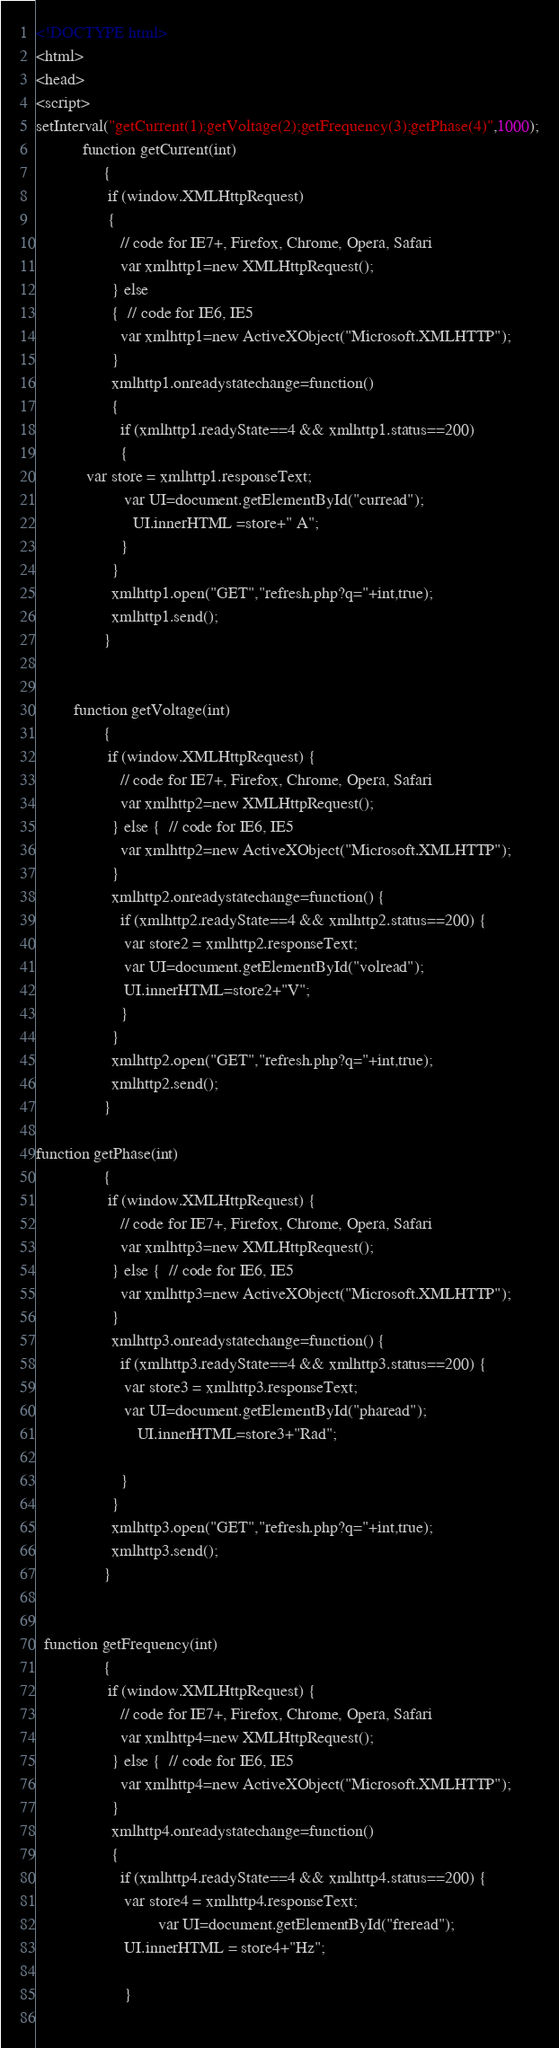Convert code to text. <code><loc_0><loc_0><loc_500><loc_500><_HTML_><!DOCTYPE html>
<html>
<head>
<script>
setInterval("getCurrent(1);getVoltage(2);getFrequency(3);getPhase(4)",1000);
           function getCurrent(int) 
				{
				 if (window.XMLHttpRequest)
				 {
					// code for IE7+, Firefox, Chrome, Opera, Safari
					var xmlhttp1=new XMLHttpRequest();
				  } else 
				  {  // code for IE6, IE5
					var xmlhttp1=new ActiveXObject("Microsoft.XMLHTTP");
				  }
				  xmlhttp1.onreadystatechange=function()
				  {
					if (xmlhttp1.readyState==4 && xmlhttp1.status==200)
					{
			var store = xmlhttp1.responseText;
					 var UI=document.getElementById("curread");
					   UI.innerHTML =store+" A";
					}
				  }
				  xmlhttp1.open("GET","refresh.php?q="+int,true);
				  xmlhttp1.send();
				}
				
				
		 function getVoltage(int) 
				{
				 if (window.XMLHttpRequest) {
					// code for IE7+, Firefox, Chrome, Opera, Safari
					var xmlhttp2=new XMLHttpRequest();
				  } else {  // code for IE6, IE5
					var xmlhttp2=new ActiveXObject("Microsoft.XMLHTTP");
				  }
				  xmlhttp2.onreadystatechange=function() {
					if (xmlhttp2.readyState==4 && xmlhttp2.status==200) {
					 var store2 = xmlhttp2.responseText;
					 var UI=document.getElementById("volread");
					 UI.innerHTML=store2+"V";
					}
				  }
				  xmlhttp2.open("GET","refresh.php?q="+int,true);
				  xmlhttp2.send();
				}

function getPhase(int) 
				{
				 if (window.XMLHttpRequest) {
					// code for IE7+, Firefox, Chrome, Opera, Safari
					var xmlhttp3=new XMLHttpRequest();
				  } else {  // code for IE6, IE5
					var xmlhttp3=new ActiveXObject("Microsoft.XMLHTTP");
				  }
				  xmlhttp3.onreadystatechange=function() {
					if (xmlhttp3.readyState==4 && xmlhttp3.status==200) {
					 var store3 = xmlhttp3.responseText;
					 var UI=document.getElementById("pharead");
					    UI.innerHTML=store3+"Rad";
				
					}
				  }
				  xmlhttp3.open("GET","refresh.php?q="+int,true);
				  xmlhttp3.send();
				}

 
  function getFrequency(int) 
				{
				 if (window.XMLHttpRequest) {
					// code for IE7+, Firefox, Chrome, Opera, Safari
					var xmlhttp4=new XMLHttpRequest();
				  } else {  // code for IE6, IE5
					var xmlhttp4=new ActiveXObject("Microsoft.XMLHTTP");
				  }
				  xmlhttp4.onreadystatechange=function() 
				  {
					if (xmlhttp4.readyState==4 && xmlhttp4.status==200) {
					 var store4 = xmlhttp4.responseText;
							 var UI=document.getElementById("freread");
					 UI.innerHTML = store4+"Hz";
					
					 }
				</code> 